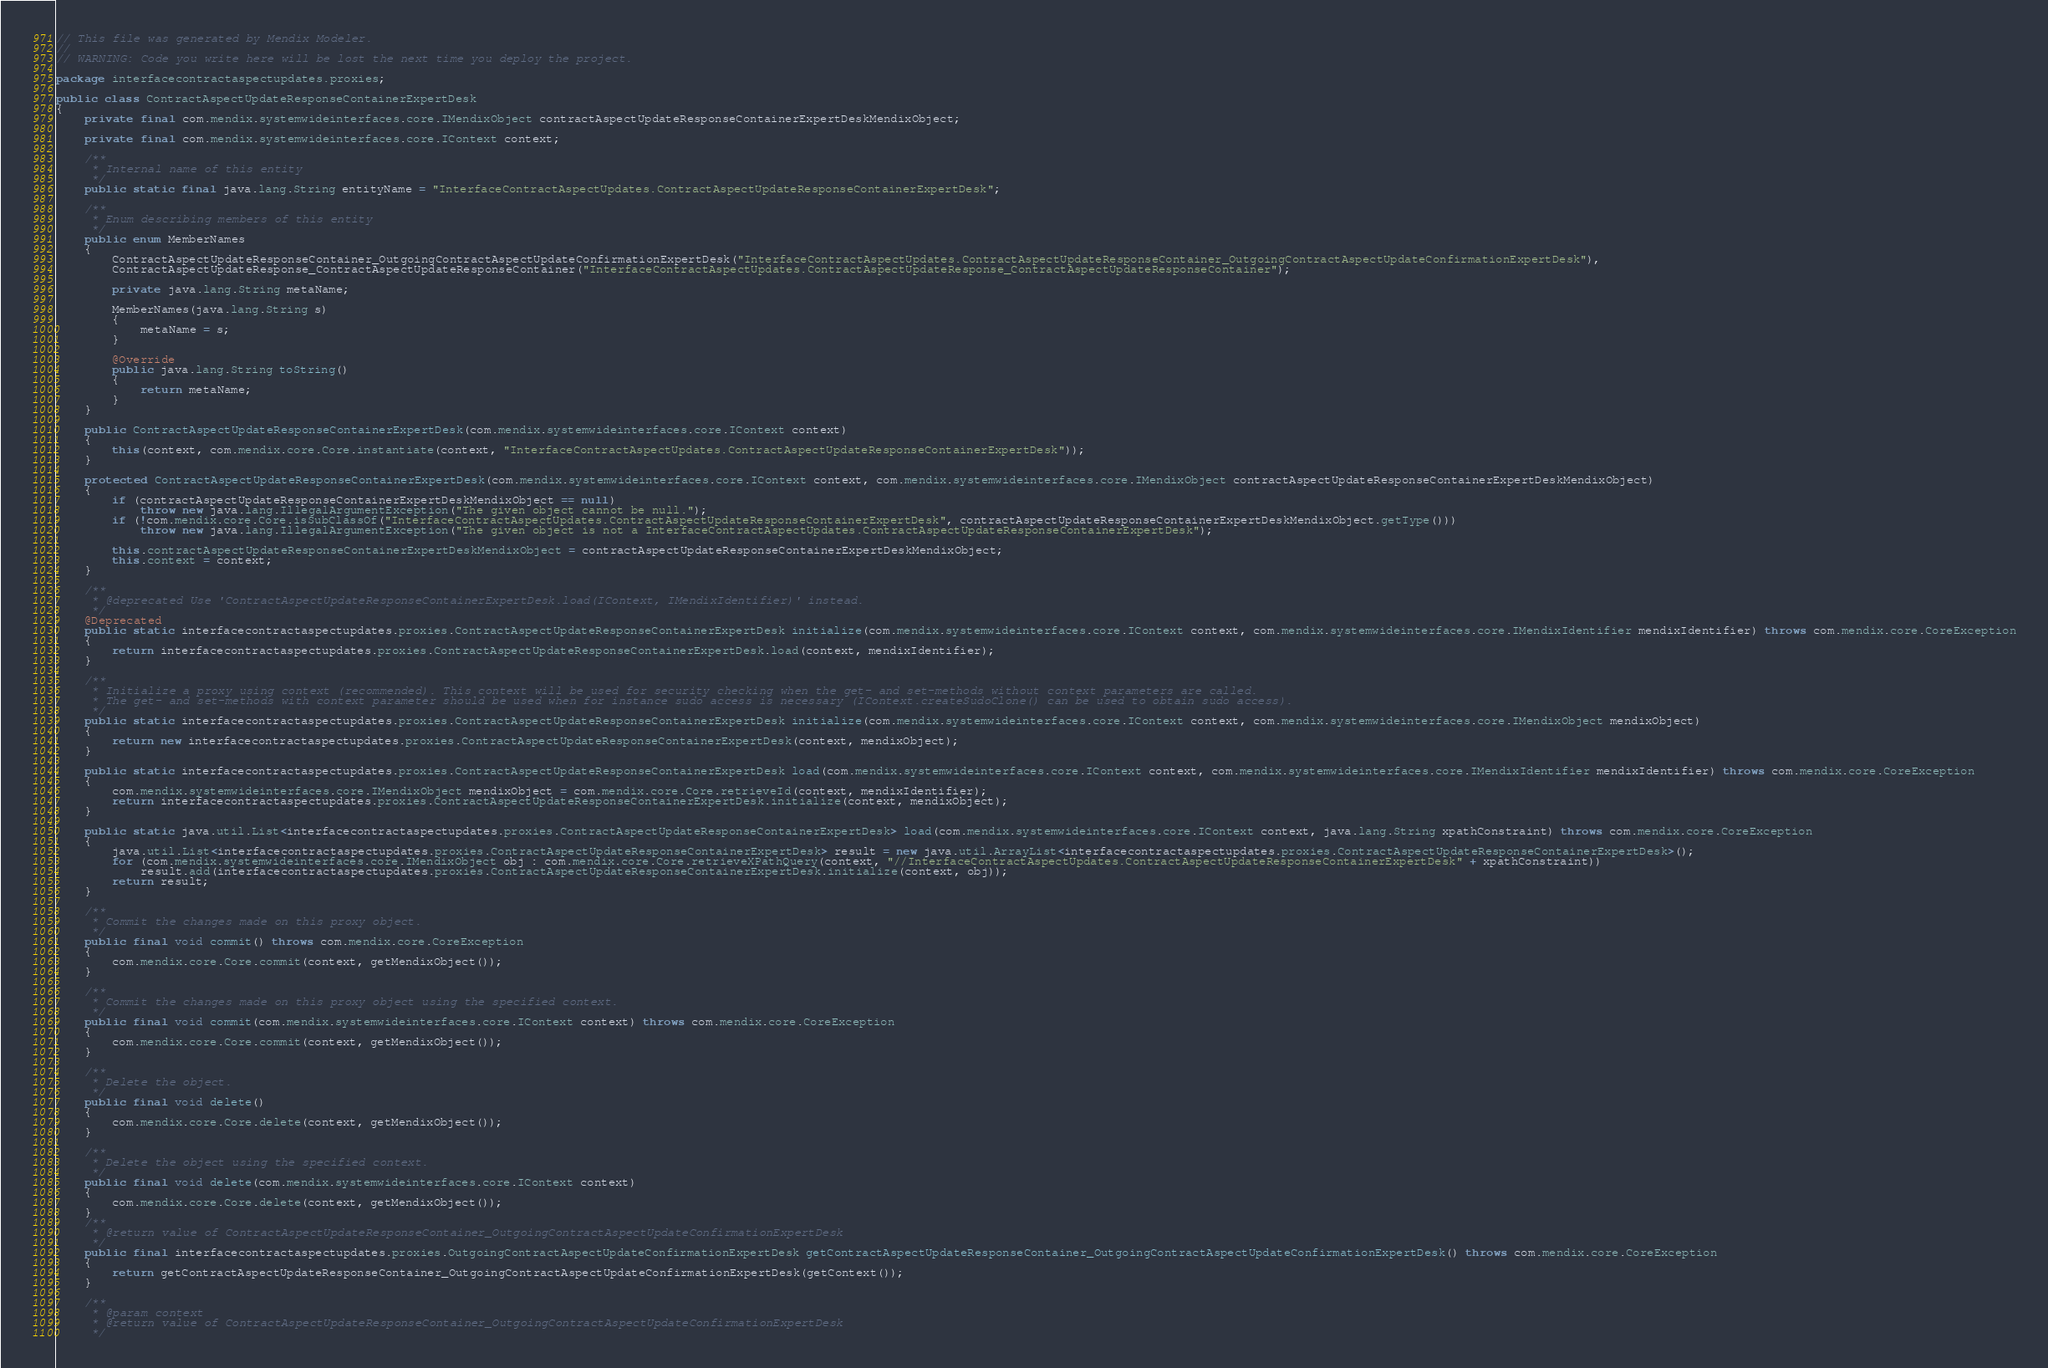<code> <loc_0><loc_0><loc_500><loc_500><_Java_>// This file was generated by Mendix Modeler.
//
// WARNING: Code you write here will be lost the next time you deploy the project.

package interfacecontractaspectupdates.proxies;

public class ContractAspectUpdateResponseContainerExpertDesk
{
	private final com.mendix.systemwideinterfaces.core.IMendixObject contractAspectUpdateResponseContainerExpertDeskMendixObject;

	private final com.mendix.systemwideinterfaces.core.IContext context;

	/**
	 * Internal name of this entity
	 */
	public static final java.lang.String entityName = "InterfaceContractAspectUpdates.ContractAspectUpdateResponseContainerExpertDesk";

	/**
	 * Enum describing members of this entity
	 */
	public enum MemberNames
	{
		ContractAspectUpdateResponseContainer_OutgoingContractAspectUpdateConfirmationExpertDesk("InterfaceContractAspectUpdates.ContractAspectUpdateResponseContainer_OutgoingContractAspectUpdateConfirmationExpertDesk"),
		ContractAspectUpdateResponse_ContractAspectUpdateResponseContainer("InterfaceContractAspectUpdates.ContractAspectUpdateResponse_ContractAspectUpdateResponseContainer");

		private java.lang.String metaName;

		MemberNames(java.lang.String s)
		{
			metaName = s;
		}

		@Override
		public java.lang.String toString()
		{
			return metaName;
		}
	}

	public ContractAspectUpdateResponseContainerExpertDesk(com.mendix.systemwideinterfaces.core.IContext context)
	{
		this(context, com.mendix.core.Core.instantiate(context, "InterfaceContractAspectUpdates.ContractAspectUpdateResponseContainerExpertDesk"));
	}

	protected ContractAspectUpdateResponseContainerExpertDesk(com.mendix.systemwideinterfaces.core.IContext context, com.mendix.systemwideinterfaces.core.IMendixObject contractAspectUpdateResponseContainerExpertDeskMendixObject)
	{
		if (contractAspectUpdateResponseContainerExpertDeskMendixObject == null)
			throw new java.lang.IllegalArgumentException("The given object cannot be null.");
		if (!com.mendix.core.Core.isSubClassOf("InterfaceContractAspectUpdates.ContractAspectUpdateResponseContainerExpertDesk", contractAspectUpdateResponseContainerExpertDeskMendixObject.getType()))
			throw new java.lang.IllegalArgumentException("The given object is not a InterfaceContractAspectUpdates.ContractAspectUpdateResponseContainerExpertDesk");

		this.contractAspectUpdateResponseContainerExpertDeskMendixObject = contractAspectUpdateResponseContainerExpertDeskMendixObject;
		this.context = context;
	}

	/**
	 * @deprecated Use 'ContractAspectUpdateResponseContainerExpertDesk.load(IContext, IMendixIdentifier)' instead.
	 */
	@Deprecated
	public static interfacecontractaspectupdates.proxies.ContractAspectUpdateResponseContainerExpertDesk initialize(com.mendix.systemwideinterfaces.core.IContext context, com.mendix.systemwideinterfaces.core.IMendixIdentifier mendixIdentifier) throws com.mendix.core.CoreException
	{
		return interfacecontractaspectupdates.proxies.ContractAspectUpdateResponseContainerExpertDesk.load(context, mendixIdentifier);
	}

	/**
	 * Initialize a proxy using context (recommended). This context will be used for security checking when the get- and set-methods without context parameters are called.
	 * The get- and set-methods with context parameter should be used when for instance sudo access is necessary (IContext.createSudoClone() can be used to obtain sudo access).
	 */
	public static interfacecontractaspectupdates.proxies.ContractAspectUpdateResponseContainerExpertDesk initialize(com.mendix.systemwideinterfaces.core.IContext context, com.mendix.systemwideinterfaces.core.IMendixObject mendixObject)
	{
		return new interfacecontractaspectupdates.proxies.ContractAspectUpdateResponseContainerExpertDesk(context, mendixObject);
	}

	public static interfacecontractaspectupdates.proxies.ContractAspectUpdateResponseContainerExpertDesk load(com.mendix.systemwideinterfaces.core.IContext context, com.mendix.systemwideinterfaces.core.IMendixIdentifier mendixIdentifier) throws com.mendix.core.CoreException
	{
		com.mendix.systemwideinterfaces.core.IMendixObject mendixObject = com.mendix.core.Core.retrieveId(context, mendixIdentifier);
		return interfacecontractaspectupdates.proxies.ContractAspectUpdateResponseContainerExpertDesk.initialize(context, mendixObject);
	}

	public static java.util.List<interfacecontractaspectupdates.proxies.ContractAspectUpdateResponseContainerExpertDesk> load(com.mendix.systemwideinterfaces.core.IContext context, java.lang.String xpathConstraint) throws com.mendix.core.CoreException
	{
		java.util.List<interfacecontractaspectupdates.proxies.ContractAspectUpdateResponseContainerExpertDesk> result = new java.util.ArrayList<interfacecontractaspectupdates.proxies.ContractAspectUpdateResponseContainerExpertDesk>();
		for (com.mendix.systemwideinterfaces.core.IMendixObject obj : com.mendix.core.Core.retrieveXPathQuery(context, "//InterfaceContractAspectUpdates.ContractAspectUpdateResponseContainerExpertDesk" + xpathConstraint))
			result.add(interfacecontractaspectupdates.proxies.ContractAspectUpdateResponseContainerExpertDesk.initialize(context, obj));
		return result;
	}

	/**
	 * Commit the changes made on this proxy object.
	 */
	public final void commit() throws com.mendix.core.CoreException
	{
		com.mendix.core.Core.commit(context, getMendixObject());
	}

	/**
	 * Commit the changes made on this proxy object using the specified context.
	 */
	public final void commit(com.mendix.systemwideinterfaces.core.IContext context) throws com.mendix.core.CoreException
	{
		com.mendix.core.Core.commit(context, getMendixObject());
	}

	/**
	 * Delete the object.
	 */
	public final void delete()
	{
		com.mendix.core.Core.delete(context, getMendixObject());
	}

	/**
	 * Delete the object using the specified context.
	 */
	public final void delete(com.mendix.systemwideinterfaces.core.IContext context)
	{
		com.mendix.core.Core.delete(context, getMendixObject());
	}
	/**
	 * @return value of ContractAspectUpdateResponseContainer_OutgoingContractAspectUpdateConfirmationExpertDesk
	 */
	public final interfacecontractaspectupdates.proxies.OutgoingContractAspectUpdateConfirmationExpertDesk getContractAspectUpdateResponseContainer_OutgoingContractAspectUpdateConfirmationExpertDesk() throws com.mendix.core.CoreException
	{
		return getContractAspectUpdateResponseContainer_OutgoingContractAspectUpdateConfirmationExpertDesk(getContext());
	}

	/**
	 * @param context
	 * @return value of ContractAspectUpdateResponseContainer_OutgoingContractAspectUpdateConfirmationExpertDesk
	 */</code> 